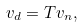Convert formula to latex. <formula><loc_0><loc_0><loc_500><loc_500>v _ { d } = T v _ { n } ,</formula> 